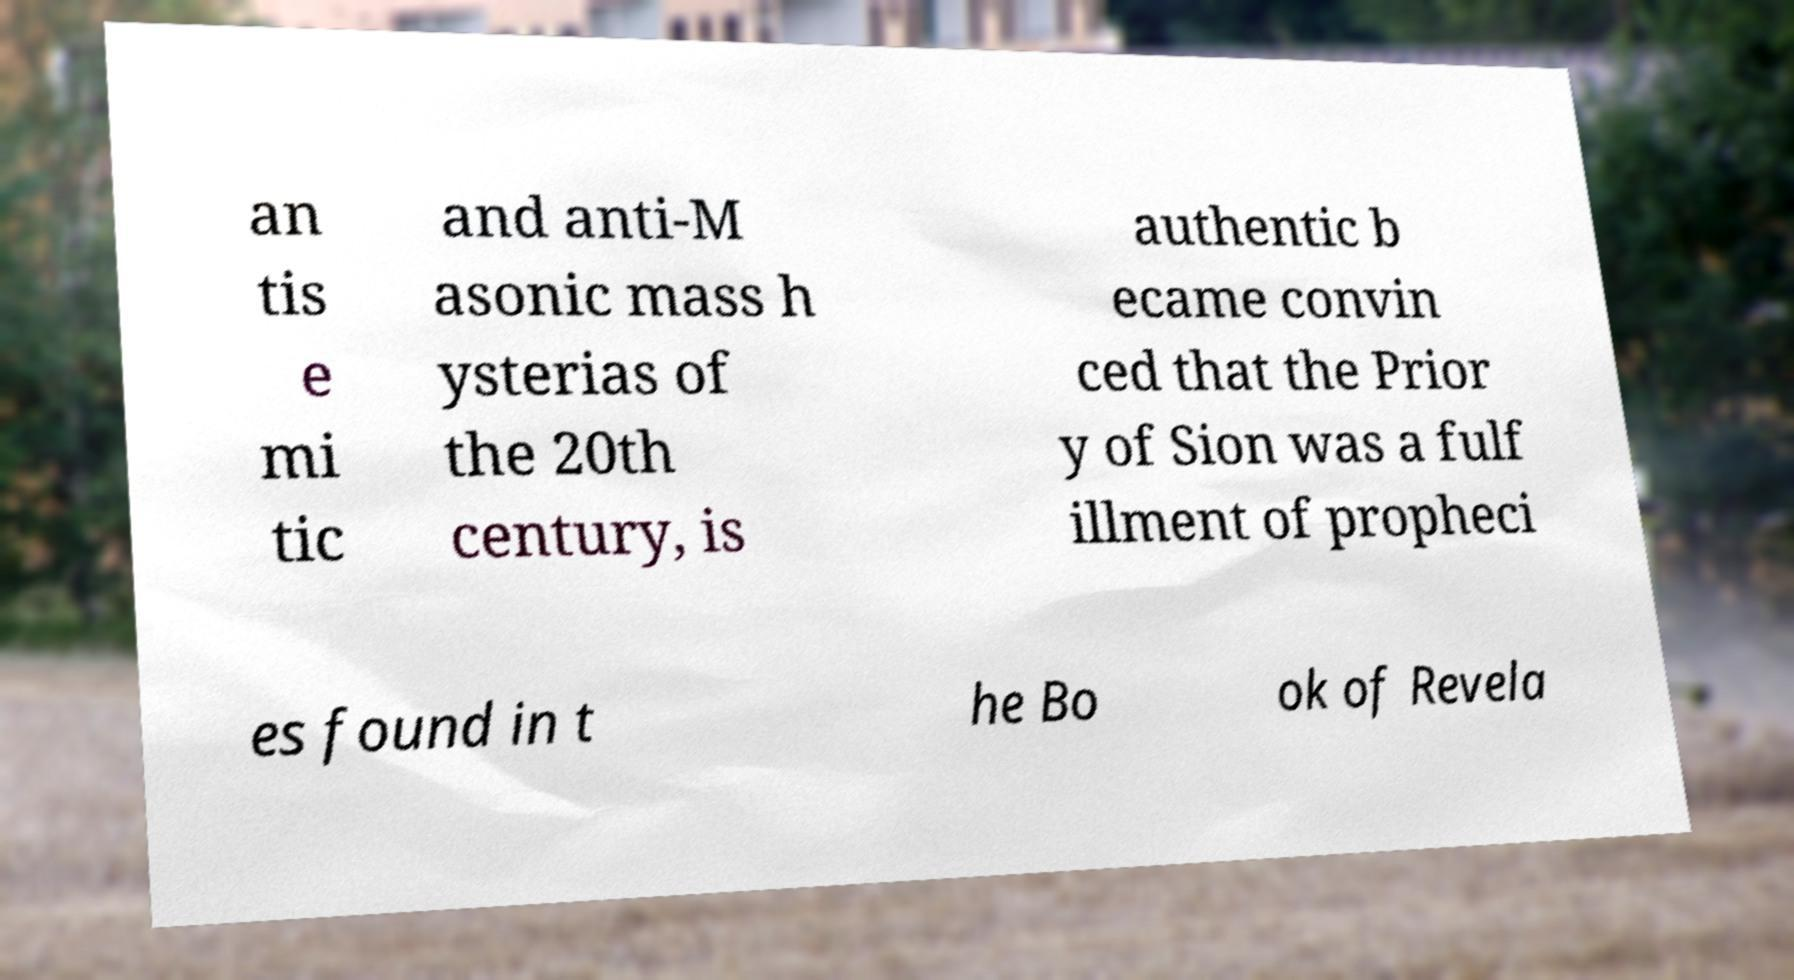Could you extract and type out the text from this image? an tis e mi tic and anti-M asonic mass h ysterias of the 20th century, is authentic b ecame convin ced that the Prior y of Sion was a fulf illment of propheci es found in t he Bo ok of Revela 